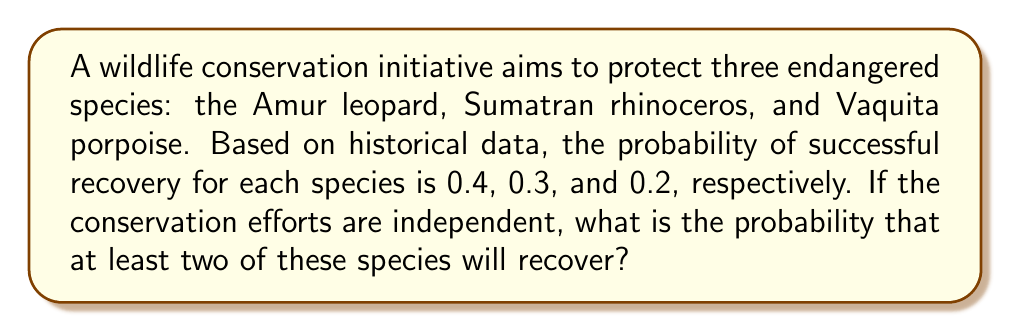Teach me how to tackle this problem. Let's approach this step-by-step:

1) First, let's define our events:
   A: Amur leopard recovers (P(A) = 0.4)
   B: Sumatran rhinoceros recovers (P(B) = 0.3)
   C: Vaquita porpoise recovers (P(C) = 0.2)

2) We want the probability of at least two species recovering. This is easier to calculate by subtracting the probability of 0 or 1 species recovering from 1.

3) Probability of 0 species recovering:
   $P(\text{none}) = (1-0.4)(1-0.3)(1-0.2) = 0.6 \times 0.7 \times 0.8 = 0.336$

4) Probability of exactly 1 species recovering:
   $P(\text{one}) = 0.4 \times 0.7 \times 0.8 + 0.6 \times 0.3 \times 0.8 + 0.6 \times 0.7 \times 0.2$
                  $= 0.224 + 0.144 + 0.084 = 0.452$

5) Therefore, the probability of at least two species recovering is:
   $P(\text{at least two}) = 1 - P(\text{none}) - P(\text{one})$
                            $= 1 - 0.336 - 0.452$
                            $= 0.212$
Answer: 0.212 